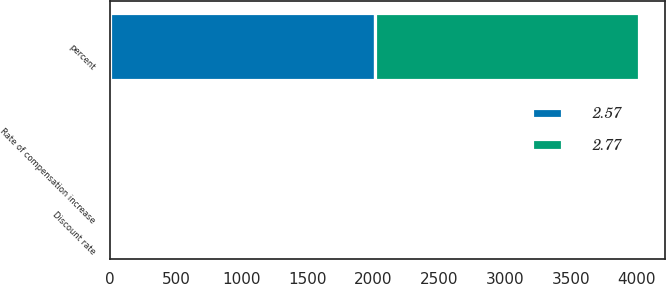<chart> <loc_0><loc_0><loc_500><loc_500><stacked_bar_chart><ecel><fcel>percent<fcel>Discount rate<fcel>Rate of compensation increase<nl><fcel>2.57<fcel>2009<fcel>5.75<fcel>3.5<nl><fcel>2.77<fcel>2008<fcel>7<fcel>3.5<nl></chart> 